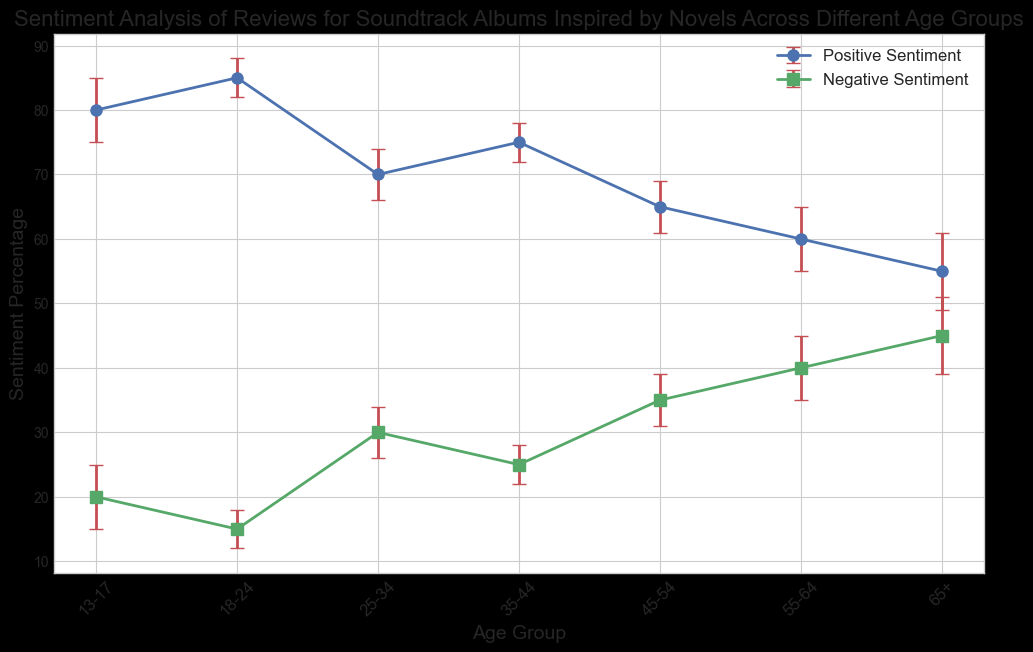What is the age group with the highest percentage of positive sentiment? By looking at the positive sentiment percentages, we can see that the 18-24 age group has the highest percentage at 85%.
Answer: 18-24 Which age group has the largest margin of error? Examining the margin of error values, the age group 65+ has the largest margin of error at 6%.
Answer: 65+ How do the positive and negative sentiments compare for the 25-34 age group? For the 25-34 age group, the positive sentiment is 70% and the negative sentiment is 30%. This means that positive sentiment is higher by 40%.
Answer: Positive sentiment is higher by 40% Which age group shows the smallest difference between positive and negative sentiments? The 65+ age group has a positive sentiment of 55% and a negative sentiment of 45%, giving a difference of 10%, which is the smallest difference among all age groups.
Answer: 65+ What is the overall trend in positive sentiment as age increases? Observing the trend, the positive sentiment percentage generally decreases as the age group increases from 13-17 to 65+.
Answer: Decreases What is the combined sentiment (positive + negative) for the 35-44 age group? Adding the positive sentiment of 75% to the negative sentiment of 25% for the 35-44 age group, we get a combined sentiment of 100%.
Answer: 100% Between which age groups does the percentage of negative sentiment increase the most? The largest jump in negative sentiment percentage is from the 18-24 age group (15%) to the 25-34 age group (30%), resulting in a 15% increase.
Answer: 18-24 to 25-34 How does the margin of error for the positive sentiment of the 55-64 age group compare to that of the 35-44 age group? The margin of error for the 55-64 age group is 5%, whereas for the 35-44 age group it is 3%. Therefore, the margin of error for the 55-64 age group is 2% higher.
Answer: 2% higher What is the mean positive sentiment percentage across all age groups? Adding up the positive sentiments (80 + 85 + 70 + 75 + 65 + 60 + 55) which equals 490, and then dividing by the 7 age groups, we get 70%.
Answer: 70% Which age group has the most similar positive and negative sentiments? The age group 65+ has a positive sentiment of 55% and a negative sentiment of 45%, yielding the closest values.
Answer: 65+ 